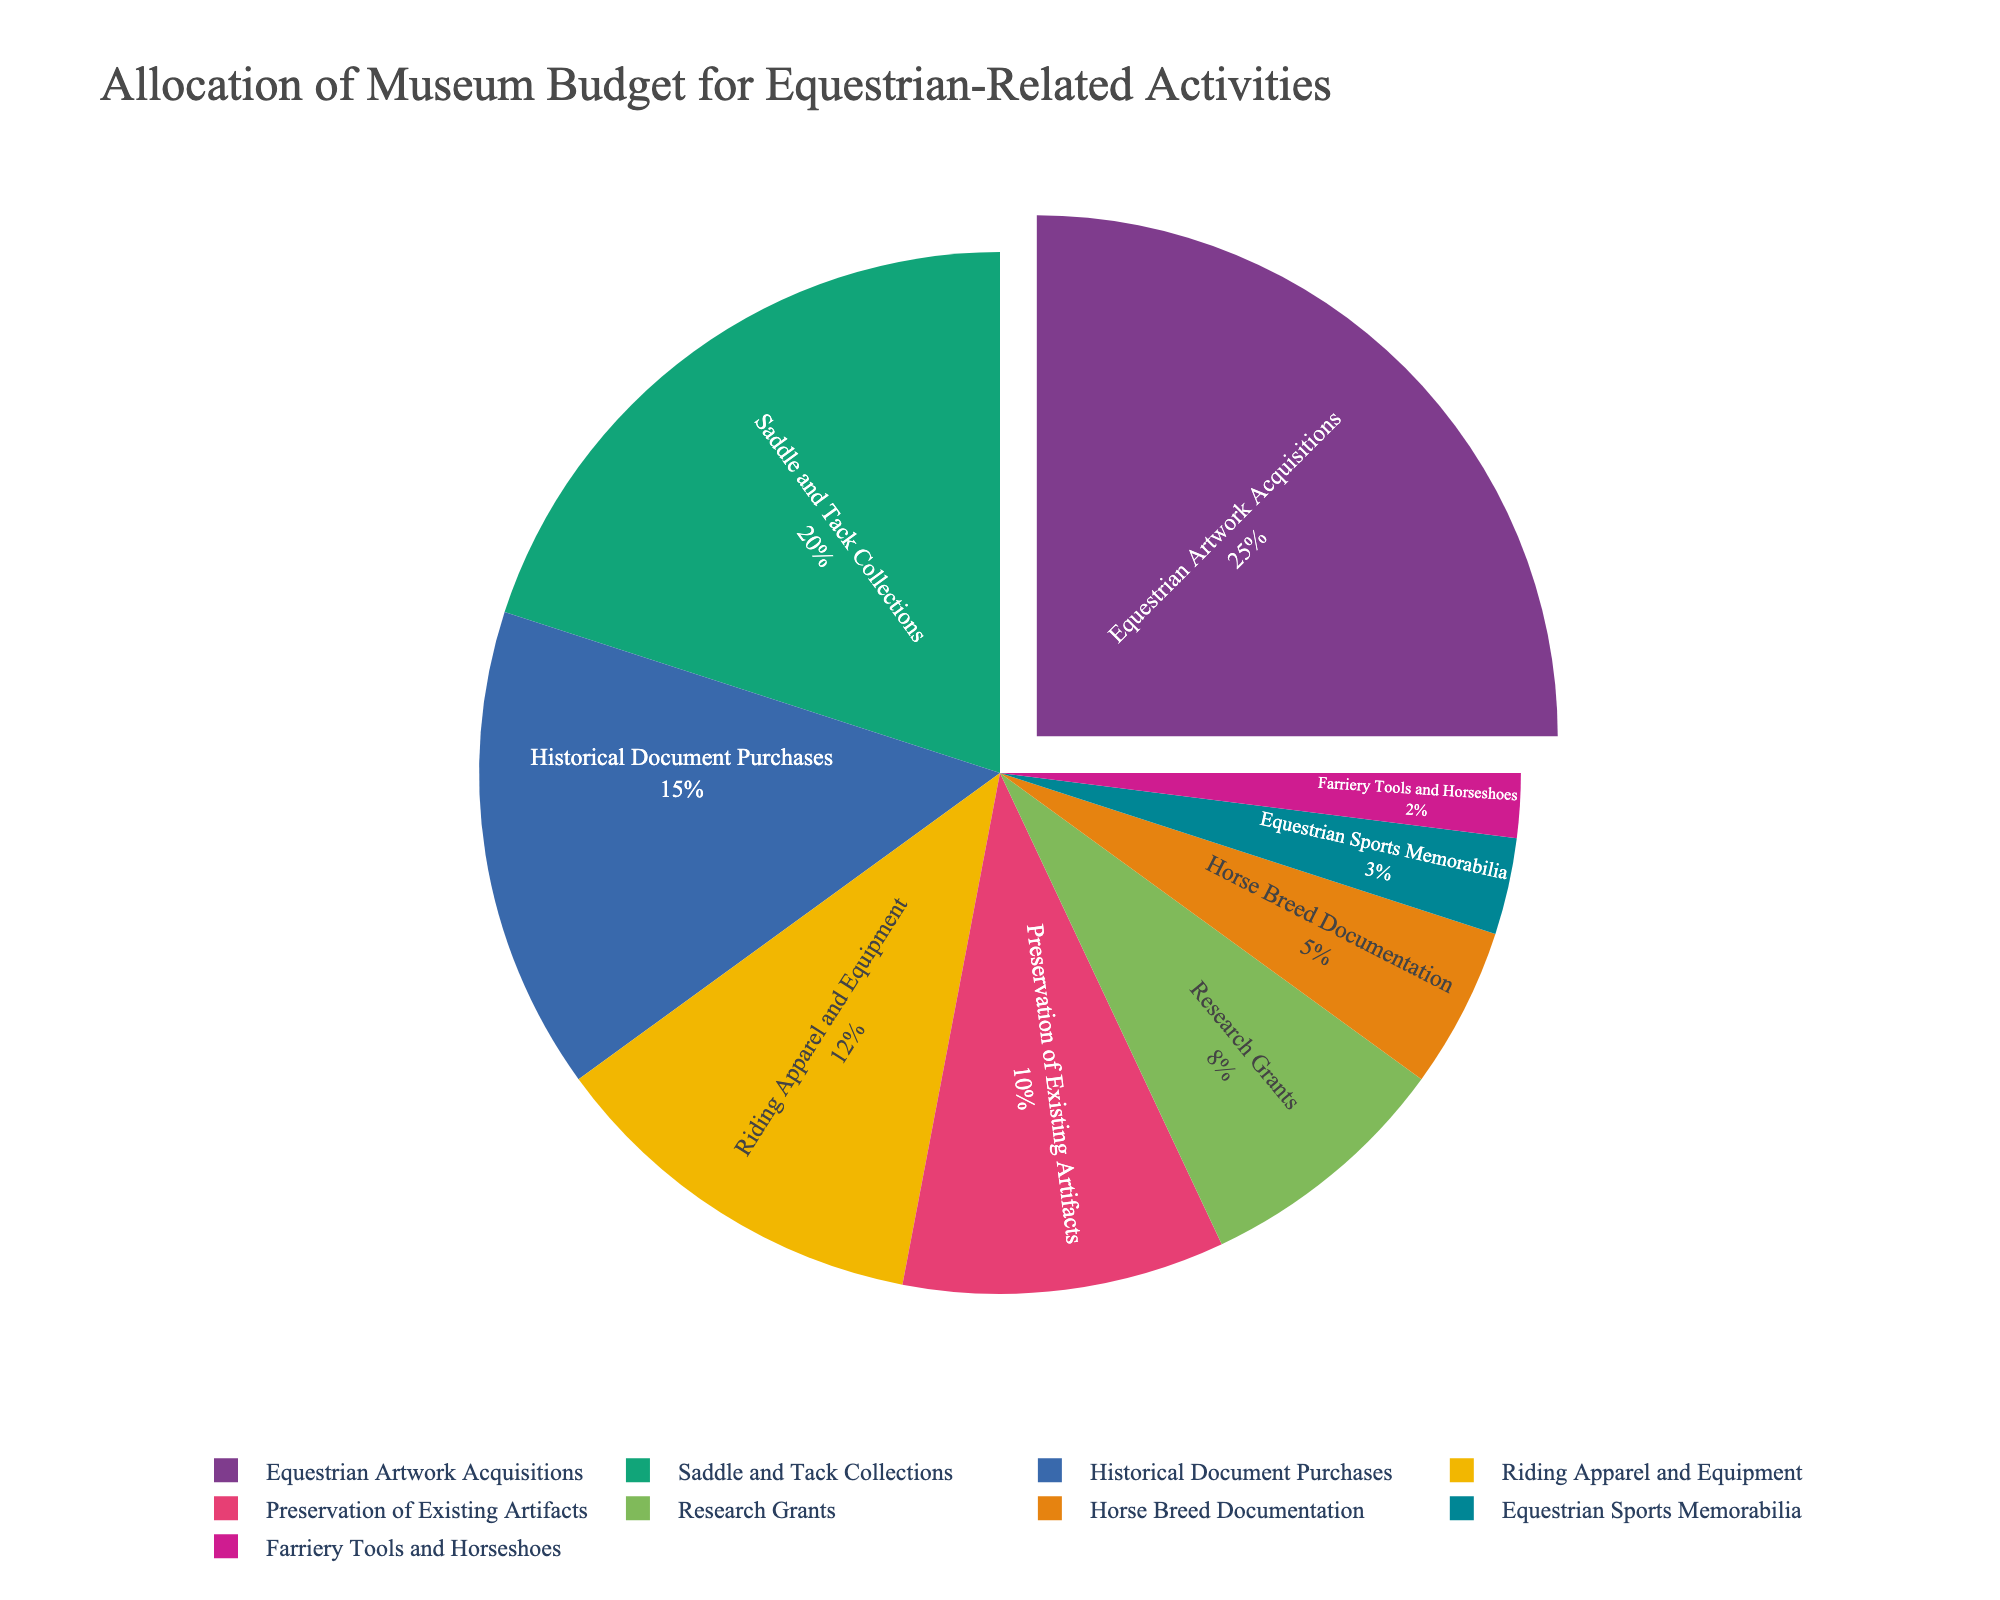What category receives the largest allocation from the museum budget? The largest section of the pie chart corresponds to "Equestrian Artwork Acquisitions" at 25%. To determine the largest allocation, identify the category with the highest percentage.
Answer: Equestrian Artwork Acquisitions Which two categories together make up more than a third of the total budget? "Equestrian Artwork Acquisitions" is 25% and "Saddle and Tack Collections" is 20%. Together, they are 45%, which is more than one-third (33.33%) of the total budget.
Answer: Equestrian Artwork Acquisitions and Saddle and Tack Collections Is the budget allocation for "Riding Apparel and Equipment" higher than "Preservation of Existing Artifacts"? "Riding Apparel and Equipment" has 12%, whereas "Preservation of Existing Artifacts" has 10%. 12% is higher than 10%.
Answer: Yes What is the combined budget percentage for categories related to documentation ("Historical Document Purchases" and "Horse Breed Documentation")? "Historical Document Purchases" is 15% and "Horse Breed Documentation" is 5%. Adding them together, 15% + 5% = 20%.
Answer: 20% Which category has the smallest allocation, and what is its percentage? The smallest part of the pie chart corresponds to "Farriery Tools and Horseshoes," which has 2%.
Answer: Farriery Tools and Horseshoes, 2% How much more is allocated to "Research Grants" compared to "Farriery Tools and Horseshoes"? "Research Grants" is 8% and "Farriery Tools and Horseshoes" is 2%. The difference is 8% - 2% = 6%.
Answer: 6% Are there any categories with equal allocation percentages? No categories on the pie chart have the same percentage allocation. Each category has a distinct percentage.
Answer: No What percentage of the budget is allocated to categories related to sports ("Equestrian Sports Memorabilia") and equipment ("Riding Apparel and Equipment") combined? "Equestrian Sports Memorabilia" is 3%, and "Riding Apparel and Equipment" is 12%. Adding them together, 3% + 12% = 15%.
Answer: 15% Which category receives the second smallest allocation, and what is its percentage? The second smallest part of the pie chart corresponds to "Equestrian Sports Memorabilia," which has 3%.
Answer: Equestrian Sports Memorabilia, 3% If the combined budget for "Saddle and Tack Collections" and "Riding Apparel and Equipment" is directed to a single category, will it exceed the allocation for "Equestrian Artwork Acquisitions"? "Saddle and Tack Collections" is 20% and "Riding Apparel and Equipment" is 12%. Their combined budget is 32%, which exceeds the 25% allocation for "Equestrian Artwork Acquisitions."
Answer: Yes 